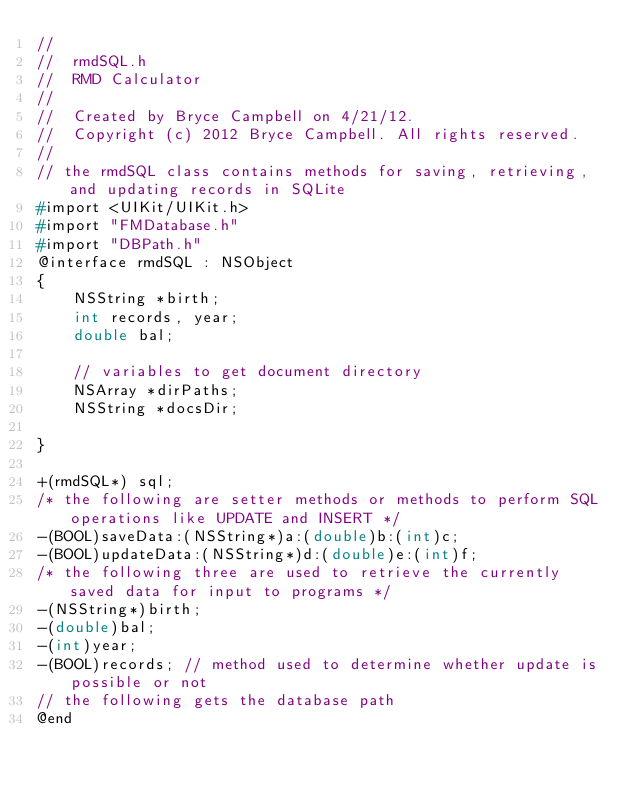<code> <loc_0><loc_0><loc_500><loc_500><_C_>//
//  rmdSQL.h
//  RMD Calculator
//
//  Created by Bryce Campbell on 4/21/12.
//  Copyright (c) 2012 Bryce Campbell. All rights reserved.
//
// the rmdSQL class contains methods for saving, retrieving, and updating records in SQLite
#import <UIKit/UIKit.h>
#import "FMDatabase.h"
#import "DBPath.h"
@interface rmdSQL : NSObject
{
    NSString *birth;
    int records, year;
    double bal;
    
    // variables to get document directory
    NSArray *dirPaths;
    NSString *docsDir;
    
}

+(rmdSQL*) sql;
/* the following are setter methods or methods to perform SQL operations like UPDATE and INSERT */
-(BOOL)saveData:(NSString*)a:(double)b:(int)c;
-(BOOL)updateData:(NSString*)d:(double)e:(int)f;
/* the following three are used to retrieve the currently saved data for input to programs */
-(NSString*)birth;
-(double)bal;
-(int)year;
-(BOOL)records; // method used to determine whether update is possible or not
// the following gets the database path
@end
</code> 